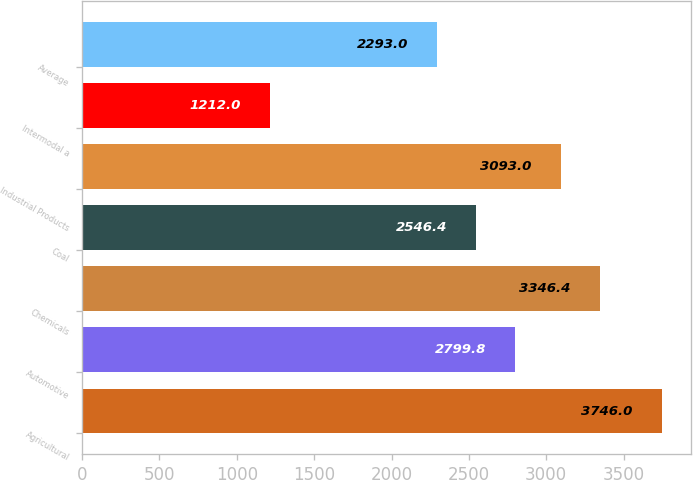Convert chart to OTSL. <chart><loc_0><loc_0><loc_500><loc_500><bar_chart><fcel>Agricultural<fcel>Automotive<fcel>Chemicals<fcel>Coal<fcel>Industrial Products<fcel>Intermodal a<fcel>Average<nl><fcel>3746<fcel>2799.8<fcel>3346.4<fcel>2546.4<fcel>3093<fcel>1212<fcel>2293<nl></chart> 